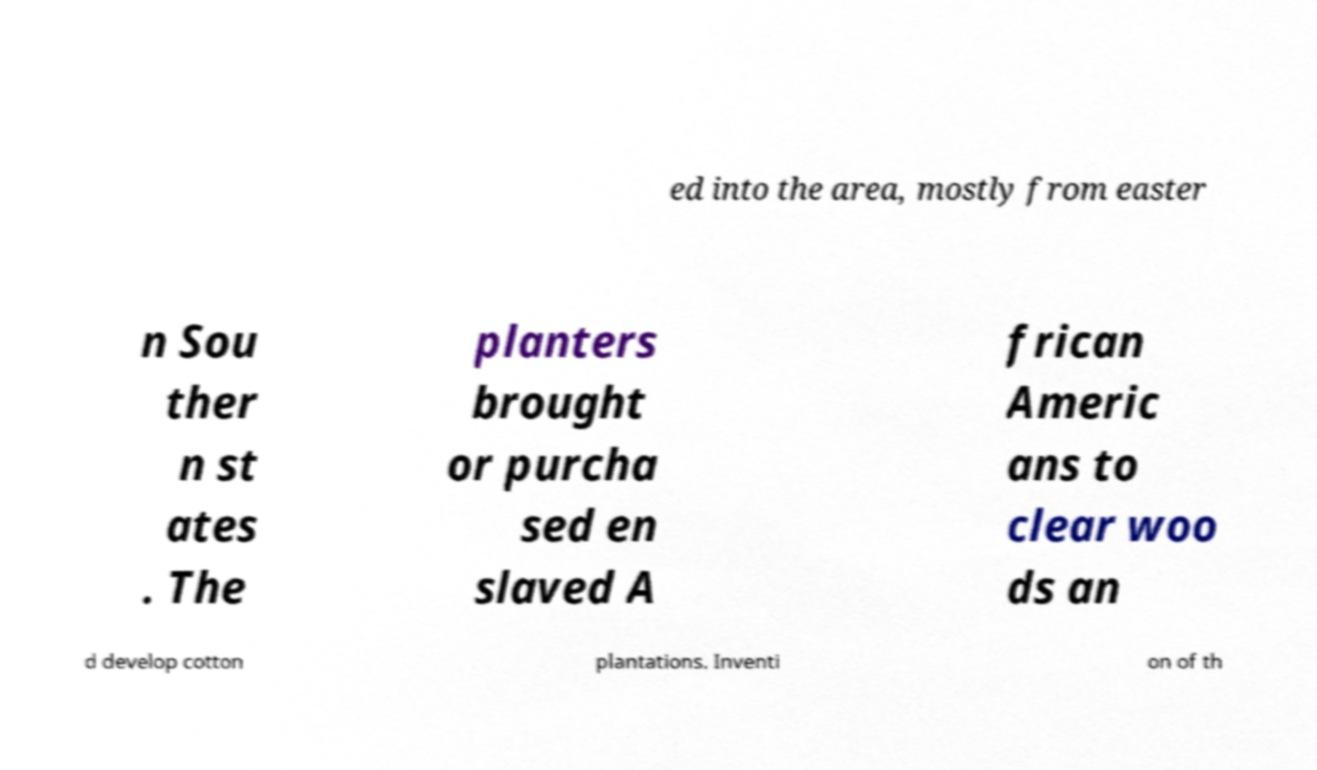Please read and relay the text visible in this image. What does it say? ed into the area, mostly from easter n Sou ther n st ates . The planters brought or purcha sed en slaved A frican Americ ans to clear woo ds an d develop cotton plantations. Inventi on of th 